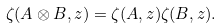Convert formula to latex. <formula><loc_0><loc_0><loc_500><loc_500>\zeta ( A \otimes B , z ) = \zeta ( A , z ) \zeta ( B , z ) .</formula> 